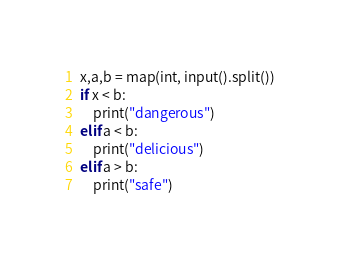<code> <loc_0><loc_0><loc_500><loc_500><_Python_>x,a,b = map(int, input().split())
if x < b:
    print("dangerous")
elif a < b:
    print("delicious")
elif a > b:
    print("safe")</code> 